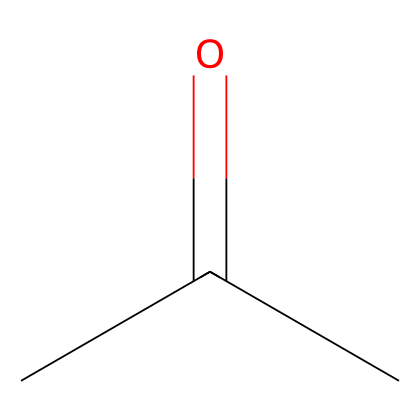how many carbon atoms are in this molecule? The SMILES representation indicates the presence of two carbon atoms in the chain: the 'CC' indicates two carbon atoms directly connected.
Answer: two what functional group is present in this chemical? The presence of the carbonyl group (C=O) indicates that this molecule has a ketone functional group, as it is indicated by the double bond to oxygen in the structure.
Answer: ketone is this chemical polar? The presence of the carbonyl group introduces polarity to the molecule because of the electronegativity difference between carbon and oxygen, making it a polar molecule overall.
Answer: yes what is the general use of this chemical in costume departments? This chemical, commonly known as acetone, is primarily used as a solvent and is effective for removing nail polish, therefore it is often utilized in makeup removal for its efficacy and quick evaporation.
Answer: solvent why is this chemical classified as flammable? This molecule contains low molecular weight and high volatility, which means it can easily evaporate and form flammable vapors at room temperature, making it pose a fire hazard.
Answer: flammable how many hydrogen atoms are in this molecule? The SMILES representation shows that there are three hydrogen atoms bonded to the first carbon (because it can form four bonds total) and one hydrogen bonded to the second carbon (which has a carbonyl), giving a total of eight hydrogens.
Answer: eight 